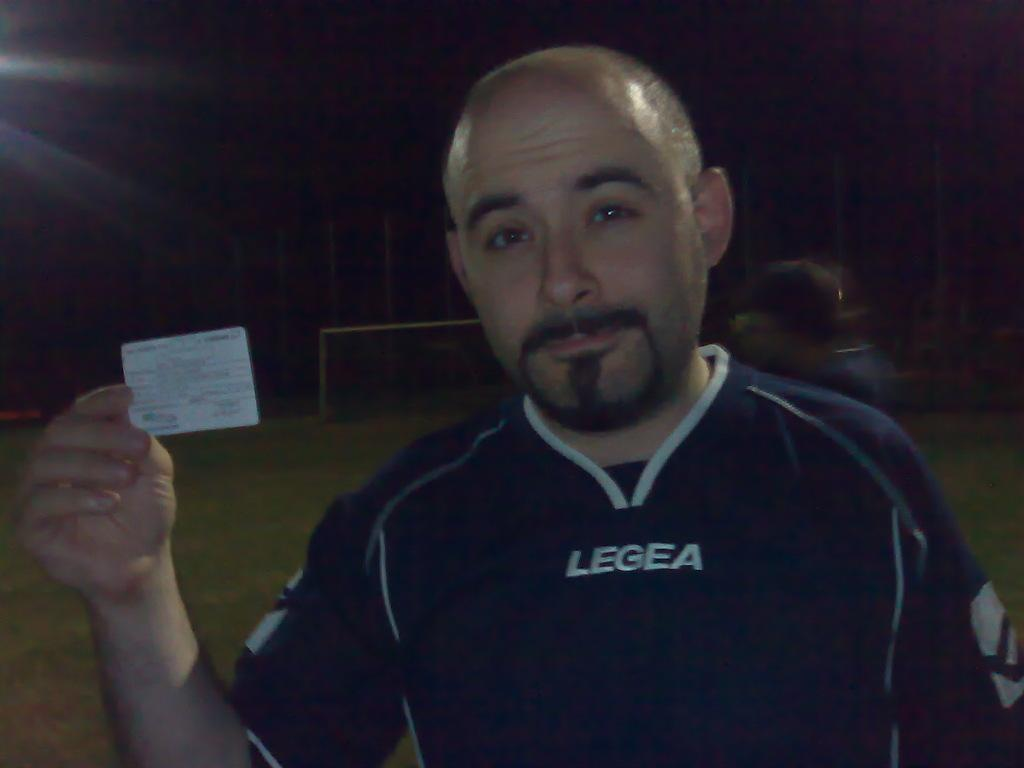What is the main subject of the image? There is a man standing in the center of the image. What is the man holding in the image? The man is holding a card. What can be seen in the background of the image? There are poles and a light visible in the background. What type of pickle is on the bed in the image? There is no pickle or bed present in the image. What noise can be heard coming from the bedroom in the image? There is no bedroom or noise present in the image. 